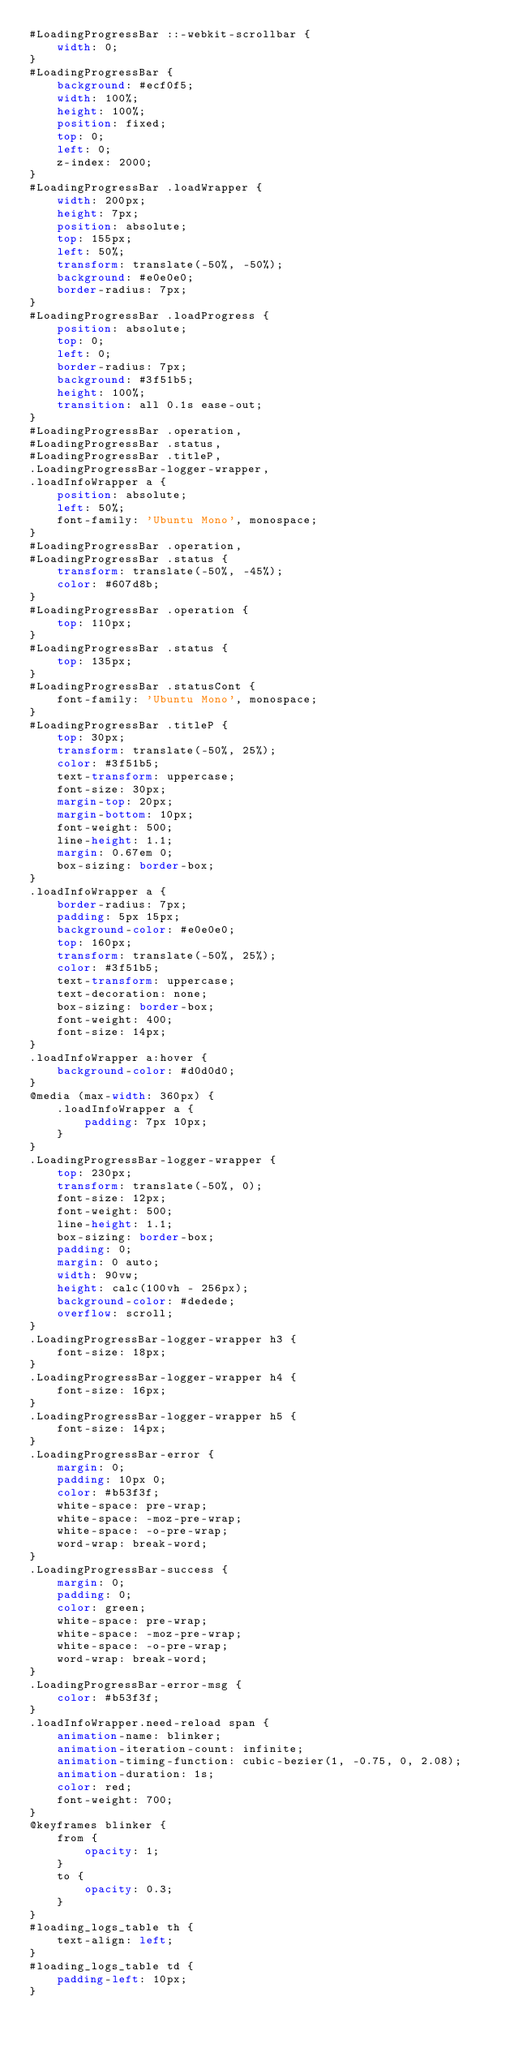<code> <loc_0><loc_0><loc_500><loc_500><_CSS_>#LoadingProgressBar ::-webkit-scrollbar {
    width: 0;
}
#LoadingProgressBar {
    background: #ecf0f5;
    width: 100%;
    height: 100%;
    position: fixed;
    top: 0;
    left: 0;
    z-index: 2000;
}
#LoadingProgressBar .loadWrapper {
    width: 200px;
    height: 7px;
    position: absolute;
    top: 155px;
    left: 50%;
    transform: translate(-50%, -50%);
    background: #e0e0e0;
    border-radius: 7px;
}
#LoadingProgressBar .loadProgress {
    position: absolute;
    top: 0;
    left: 0;
    border-radius: 7px;
    background: #3f51b5;
    height: 100%;
    transition: all 0.1s ease-out;
}
#LoadingProgressBar .operation,
#LoadingProgressBar .status,
#LoadingProgressBar .titleP,
.LoadingProgressBar-logger-wrapper,
.loadInfoWrapper a {
    position: absolute;
    left: 50%;
    font-family: 'Ubuntu Mono', monospace;
}
#LoadingProgressBar .operation,
#LoadingProgressBar .status {
    transform: translate(-50%, -45%);
    color: #607d8b;
}
#LoadingProgressBar .operation {
    top: 110px;
}
#LoadingProgressBar .status {
    top: 135px;
}
#LoadingProgressBar .statusCont {
    font-family: 'Ubuntu Mono', monospace;
}
#LoadingProgressBar .titleP {
    top: 30px;
    transform: translate(-50%, 25%);
    color: #3f51b5;
    text-transform: uppercase;
    font-size: 30px;
    margin-top: 20px;
    margin-bottom: 10px;
    font-weight: 500;
    line-height: 1.1;
    margin: 0.67em 0;
    box-sizing: border-box;
}
.loadInfoWrapper a {
    border-radius: 7px;
    padding: 5px 15px;
    background-color: #e0e0e0;
    top: 160px;
    transform: translate(-50%, 25%);
    color: #3f51b5;
    text-transform: uppercase;
    text-decoration: none;
    box-sizing: border-box;
    font-weight: 400;
    font-size: 14px;
}
.loadInfoWrapper a:hover {
    background-color: #d0d0d0;
}
@media (max-width: 360px) {
    .loadInfoWrapper a {
        padding: 7px 10px;
    }
}
.LoadingProgressBar-logger-wrapper {
    top: 230px;
    transform: translate(-50%, 0);
    font-size: 12px;
    font-weight: 500;
    line-height: 1.1;
    box-sizing: border-box;
    padding: 0;
    margin: 0 auto;
    width: 90vw;
    height: calc(100vh - 256px);
    background-color: #dedede;
    overflow: scroll;
}
.LoadingProgressBar-logger-wrapper h3 {
    font-size: 18px;
}
.LoadingProgressBar-logger-wrapper h4 {
    font-size: 16px;
}
.LoadingProgressBar-logger-wrapper h5 {
    font-size: 14px;
}
.LoadingProgressBar-error {
    margin: 0;
    padding: 10px 0;
    color: #b53f3f;
    white-space: pre-wrap;
    white-space: -moz-pre-wrap;
    white-space: -o-pre-wrap;
    word-wrap: break-word;
}
.LoadingProgressBar-success {
    margin: 0;
    padding: 0;
    color: green;
    white-space: pre-wrap;
    white-space: -moz-pre-wrap;
    white-space: -o-pre-wrap;
    word-wrap: break-word;
}
.LoadingProgressBar-error-msg {
    color: #b53f3f;
}
.loadInfoWrapper.need-reload span {
    animation-name: blinker;
    animation-iteration-count: infinite;
    animation-timing-function: cubic-bezier(1, -0.75, 0, 2.08);
    animation-duration: 1s;
    color: red;
    font-weight: 700;
}
@keyframes blinker {
    from {
        opacity: 1;
    }
    to {
        opacity: 0.3;
    }
}
#loading_logs_table th {
    text-align: left;
}
#loading_logs_table td {
    padding-left: 10px;
}
</code> 